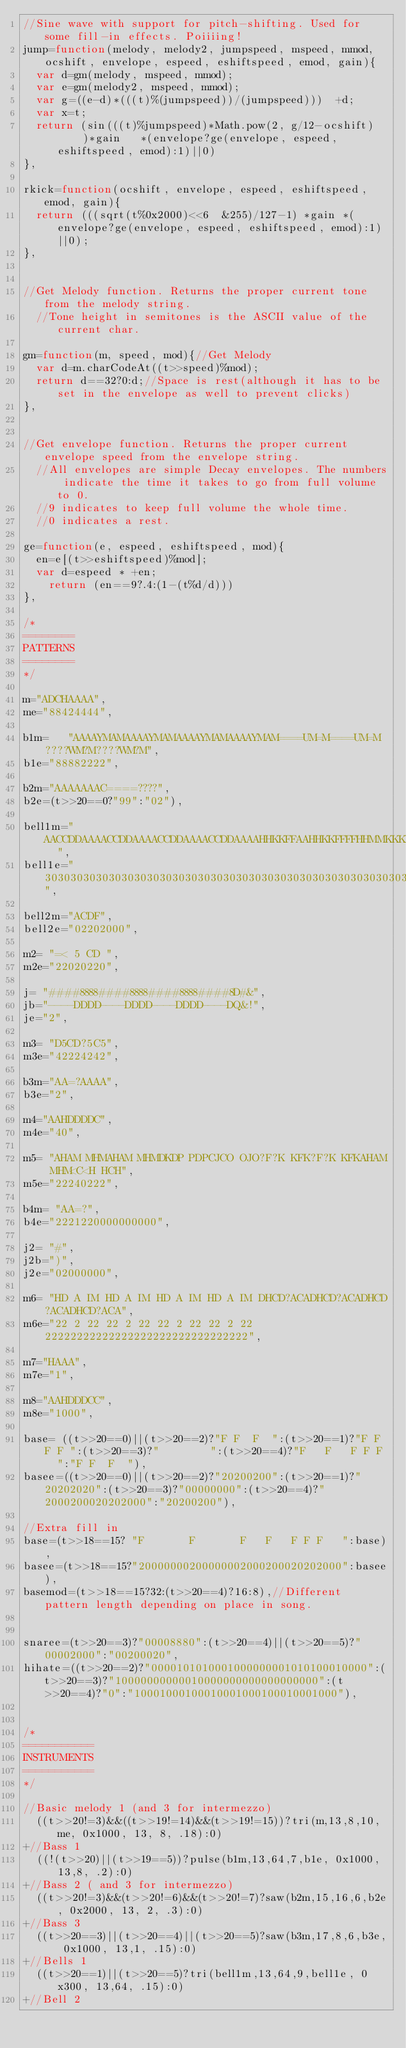Convert code to text. <code><loc_0><loc_0><loc_500><loc_500><_JavaScript_>//Sine wave with support for pitch-shifting. Used for some fill-in effects. Poiiiing!
jump=function(melody, melody2, jumpspeed, mspeed, mmod, ocshift, envelope, espeed, eshiftspeed, emod, gain){
	var d=gm(melody, mspeed, mmod);
	var e=gm(melody2, mspeed, mmod);
	var g=((e-d)*(((t)%(jumpspeed))/(jumpspeed)))  +d;
	var x=t;
	return (sin(((t)%jumpspeed)*Math.pow(2, g/12-ocshift)    	)*gain   *(envelope?ge(envelope, espeed, eshiftspeed, emod):1)||0)
},

rkick=function(ocshift, envelope, espeed, eshiftspeed, emod, gain){
	return (((sqrt(t%0x2000)<<6  &255)/127-1) *gain *(envelope?ge(envelope, espeed, eshiftspeed, emod):1)||0);
},


//Get Melody function. Returns the proper current tone from the melody string.
	//Tone height in semitones is the ASCII value of the current char.

gm=function(m, speed, mod){//Get Melody
	var d=m.charCodeAt((t>>speed)%mod);
	return d==32?0:d;//Space is rest(although it has to be set in the envelope as well to prevent clicks)
},


//Get envelope function. Returns the proper current envelope speed from the envelope string.
	//All envelopes are simple Decay envelopes. The numbers indicate the time it takes to go from full volume to 0.
	//9 indicates to keep full volume the whole time.
	//0 indicates a rest.

ge=function(e, espeed, eshiftspeed, mod){
	en=e[(t>>eshiftspeed)%mod];
	var d=espeed * +en;
		return (en==9?.4:(1-(t%d/d)))
},

/*
========
PATTERNS
========
*/

m="ADCHAAAA", 
me="88424444",

b1m=   "AAAAYMAMAAAAYMAMAAAAYMAMAAAAYMAM====UM=M====UM=M????WM?M????WM?M",
b1e="88882222",

b2m="AAAAAAAC====????",
b2e=(t>>20==0?"99":"02"),

bell1m="AACCDDAAAACCDDAAAACCDDAAAACCDDAAAAHHKKFFAAHHKKFFFFHHMMKKKPOKMM  ",
bell1e="3030303030303030303030303030303030303030303030303030303033333300",

bell2m="ACDF",
bell2e="02202000",

m2= "=< 5 CD ",
m2e="22020220",

j= "####8888####8888####8888####8D#&",
jb="----DDDD----DDDD----DDDD----DQ&!",
je="2",

m3= "D5CD?5C5",
m3e="42224242",

b3m="AA=?AAAA",
b3e="2",

m4="AAHDDDDC",
m4e="40",

m5= "AHAM MHMAHAM MHMDKDP PDPCJCO OJO?F?K KFK?F?K KFKAHAM MHM<C<H HCH",
m5e="22240222",

b4m= "AA=?",
b4e="2221220000000000",

j2= "#",
j2b=")",
j2e="02000000",

m6= "HD A IM HD A IM HD A IM HD A IM DHCD?ACADHCD?ACADHCD?ACADHCD?ACA",
m6e="22 2 22 22 2 22 22 2 22 22 2 22 22222222222222222222222222222222",

m7="HAAA",
m7e="1",

m8="AAHDDDCC",
m8e="1000",

base= ((t>>20==0)||(t>>20==2)?"F F  F  ":(t>>20==1)?"F F F F ":(t>>20==3)?"        ":(t>>20==4)?"F   F   F F F   ":"F F  F  "),
basee=((t>>20==0)||(t>>20==2)?"20200200":(t>>20==1)?"20202020":(t>>20==3)?"00000000":(t>>20==4)?"2000200020202000":"20200200"),

//Extra fill in
base=(t>>18==15? "F       F       F   F   F F F   ":base),
basee=(t>>18==15?"20000000200000002000200020202000":basee),
basemod=(t>>18==15?32:(t>>20==4)?16:8),//Different pattern length depending on place in song.


snaree=(t>>20==3)?"00008880":(t>>20==4)||(t>>20==5)?"00002000":"00200020",
hihate=((t>>20==2)?"0000101010001000000001010100010000":(t>>20==3)?"10000000000010000000000000000000":(t>>20==4)?"0":"10001000100010001000100010001000"),


/*
===========
INSTRUMENTS
===========
*/

//Basic melody 1 (and 3 for intermezzo)
	((t>>20!=3)&&((t>>19!=14)&&(t>>19!=15))?tri(m,13,8,10,me, 0x1000, 13, 8, .18):0)
+//Bass 1
	((!(t>>20)||(t>>19==5))?pulse(b1m,13,64,7,b1e, 0x1000, 13,8, .2):0)
+//Bass 2 ( and 3 for intermezzo)
	((t>>20!=3)&&(t>>20!=6)&&(t>>20!=7)?saw(b2m,15,16,6,b2e, 0x2000, 13, 2, .3):0)
+//Bass 3
	((t>>20==3)||(t>>20==4)||(t>>20==5)?saw(b3m,17,8,6,b3e, 0x1000, 13,1, .15):0)
+//Bells 1
	((t>>20==1)||(t>>20==5)?tri(bell1m,13,64,9,bell1e, 0x300, 13,64, .15):0)
+//Bell 2</code> 